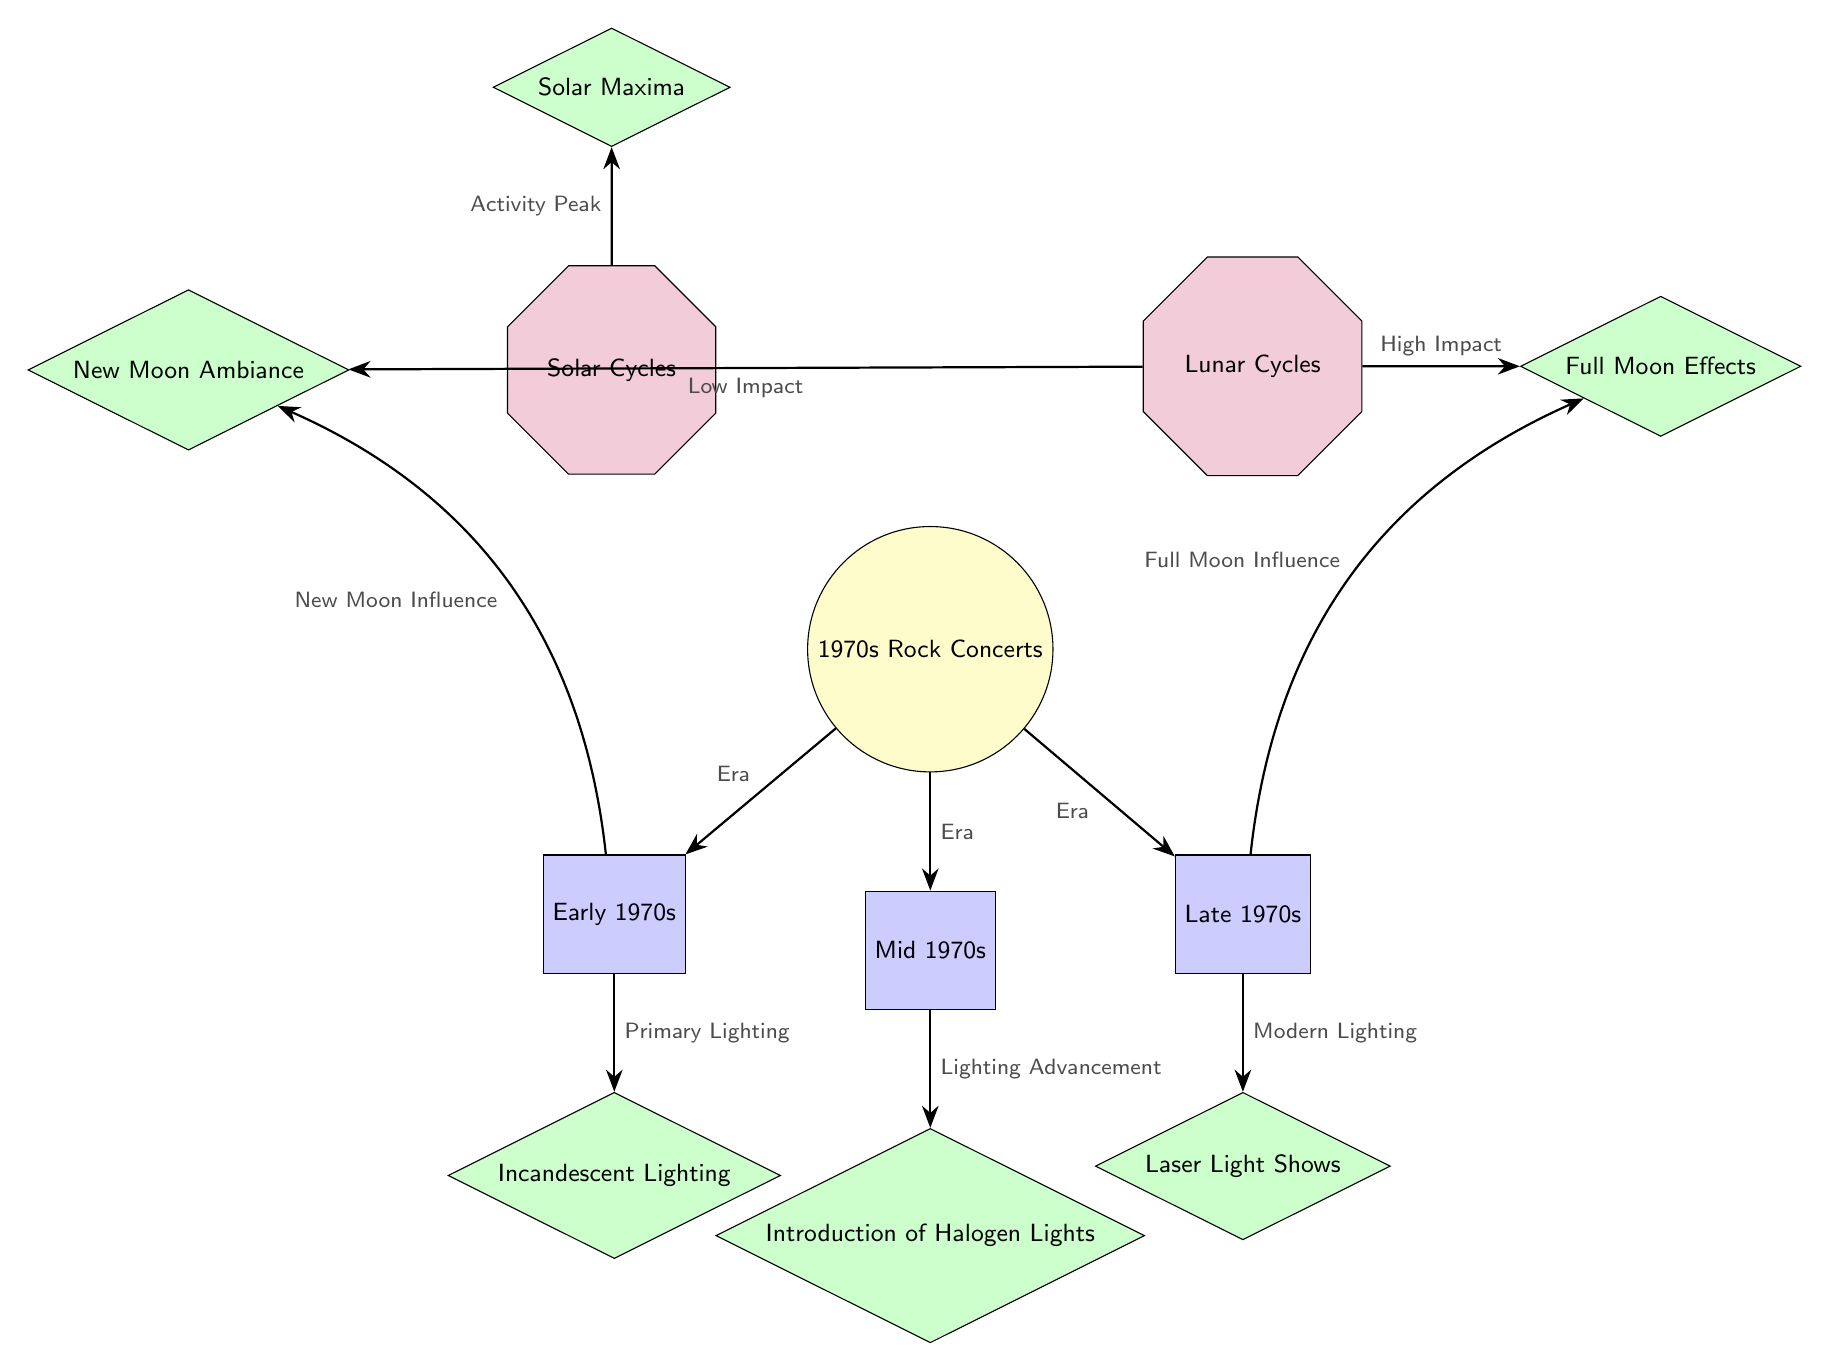What are the three eras of 1970s rock concerts indicated in the diagram? The diagram specifies three distinct eras: Early 1970s, Mid 1970s, and Late 1970s, each represented by a rectangle.
Answer: Early 1970s, Mid 1970s, Late 1970s What type of lighting was primarily used in the Early 1970s? The diagram shows that the primary lighting used in the Early 1970s is represented by a diamond labeled Incandescent Lighting.
Answer: Incandescent Lighting What kind of impact do Full Moon effects have according to the diagram? The diagram notes that Full Moon effects are associated with high impact, indicated by the flow from the lunar cycles node to the full moon effects node.
Answer: High Impact How does the New Moon influence Early 1970s concert lighting? The diagram indicates a bend in the edge labeled "New Moon Influence" showing that the New Moon has an influence on lighting in the Early 1970s. This relates the New Moon ambiance to that time.
Answer: New Moon Influence What lighting advancement was introduced in the Mid 1970s? The diagram lists the introduction of halogen lights as the significant lighting advancement during the Mid 1970s, indicated by the connection from the Mid 1970s node to the halogen lights node.
Answer: Introduction of Halogen Lights How many celestial cycle influences are indicated in the diagram? The diagram shows two celestial cycle influences: Solar Cycles and Lunar Cycles, illustrated on the upper part of the diagram, which accounts for a total of two influences.
Answer: 2 Why is the Solar Maxima relevant to the 1970s rock concerts? The diagram links the Solar Maxima to the solar cycles node, showing that solar activity peaks are significant to the context of 1970s rock concerts, indicating an influence on the overall atmosphere and themes.
Answer: Solar Maxima Which modern lighting technology ended the decade of the 1970s? According to the diagram, laser light shows are referenced as the modern lighting technology that emerged and characterized Late 1970s concerts, indicated by its connection to the Late 1970s node.
Answer: Laser Light Shows 